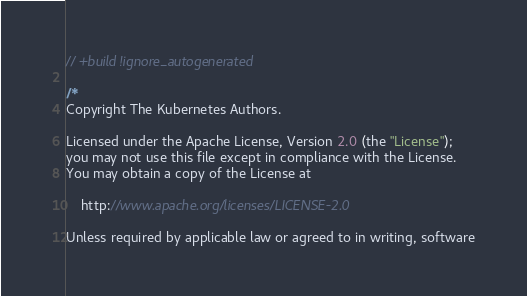Convert code to text. <code><loc_0><loc_0><loc_500><loc_500><_Go_>// +build !ignore_autogenerated

/*
Copyright The Kubernetes Authors.

Licensed under the Apache License, Version 2.0 (the "License");
you may not use this file except in compliance with the License.
You may obtain a copy of the License at

    http://www.apache.org/licenses/LICENSE-2.0

Unless required by applicable law or agreed to in writing, software</code> 